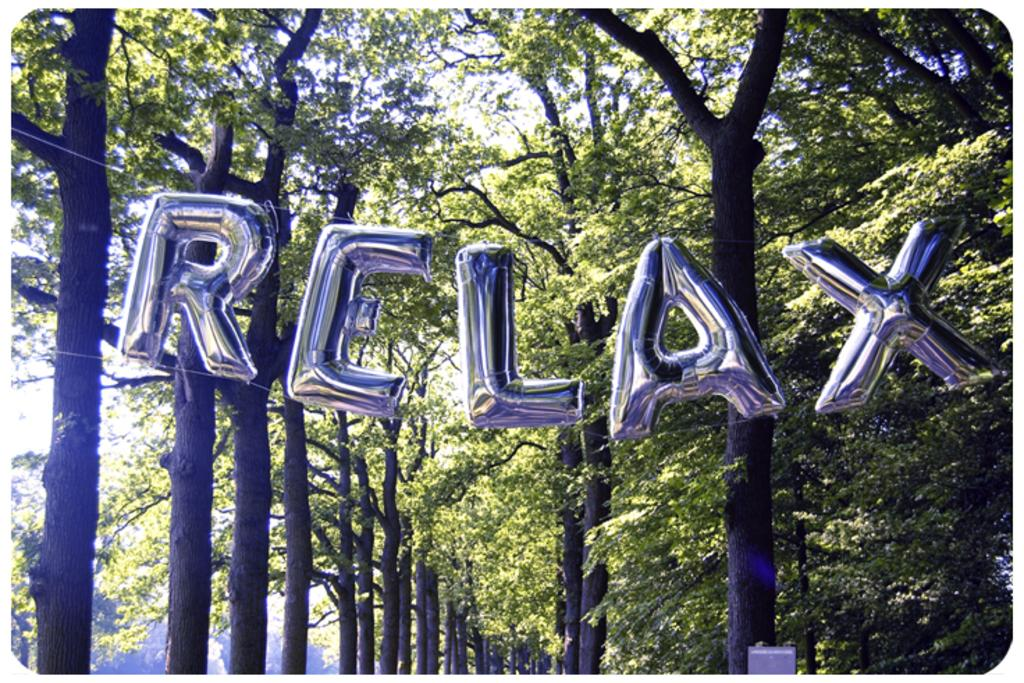What objects are present in the image? There are balloons in the image. What can be seen in the background of the image? There are trees visible behind the balloons. What country is depicted in the image? The image does not depict a country; it features balloons and trees. What type of knowledge is gained from observing the balloons in the image? The image does not convey any specific knowledge; it simply shows balloons and trees. 